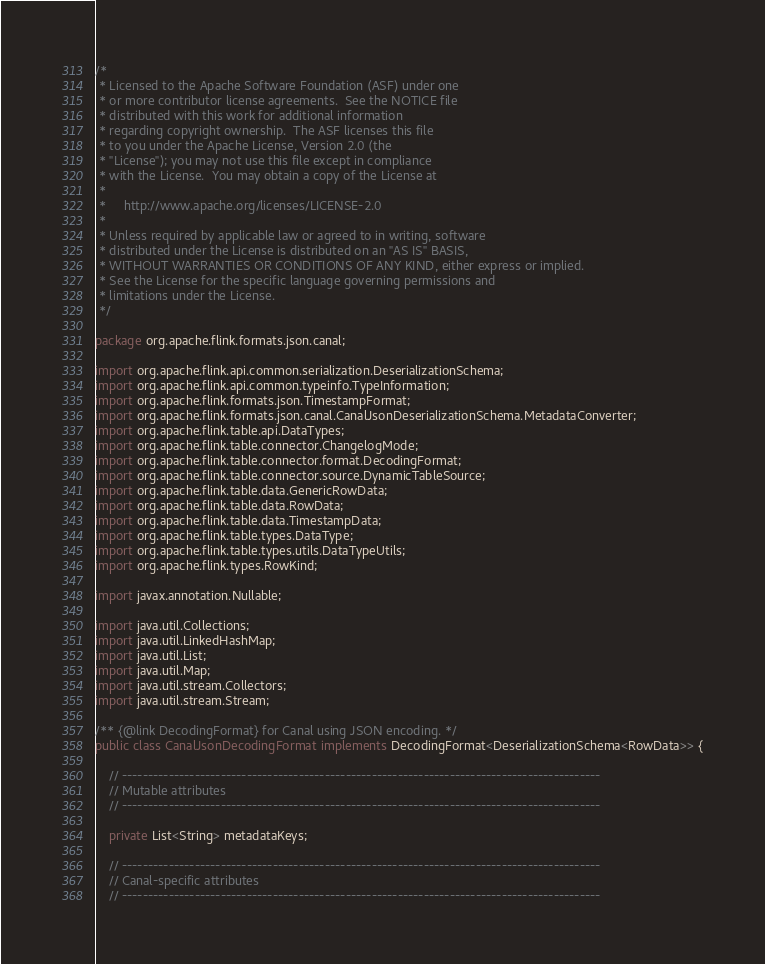Convert code to text. <code><loc_0><loc_0><loc_500><loc_500><_Java_>/*
 * Licensed to the Apache Software Foundation (ASF) under one
 * or more contributor license agreements.  See the NOTICE file
 * distributed with this work for additional information
 * regarding copyright ownership.  The ASF licenses this file
 * to you under the Apache License, Version 2.0 (the
 * "License"); you may not use this file except in compliance
 * with the License.  You may obtain a copy of the License at
 *
 *     http://www.apache.org/licenses/LICENSE-2.0
 *
 * Unless required by applicable law or agreed to in writing, software
 * distributed under the License is distributed on an "AS IS" BASIS,
 * WITHOUT WARRANTIES OR CONDITIONS OF ANY KIND, either express or implied.
 * See the License for the specific language governing permissions and
 * limitations under the License.
 */

package org.apache.flink.formats.json.canal;

import org.apache.flink.api.common.serialization.DeserializationSchema;
import org.apache.flink.api.common.typeinfo.TypeInformation;
import org.apache.flink.formats.json.TimestampFormat;
import org.apache.flink.formats.json.canal.CanalJsonDeserializationSchema.MetadataConverter;
import org.apache.flink.table.api.DataTypes;
import org.apache.flink.table.connector.ChangelogMode;
import org.apache.flink.table.connector.format.DecodingFormat;
import org.apache.flink.table.connector.source.DynamicTableSource;
import org.apache.flink.table.data.GenericRowData;
import org.apache.flink.table.data.RowData;
import org.apache.flink.table.data.TimestampData;
import org.apache.flink.table.types.DataType;
import org.apache.flink.table.types.utils.DataTypeUtils;
import org.apache.flink.types.RowKind;

import javax.annotation.Nullable;

import java.util.Collections;
import java.util.LinkedHashMap;
import java.util.List;
import java.util.Map;
import java.util.stream.Collectors;
import java.util.stream.Stream;

/** {@link DecodingFormat} for Canal using JSON encoding. */
public class CanalJsonDecodingFormat implements DecodingFormat<DeserializationSchema<RowData>> {

    // --------------------------------------------------------------------------------------------
    // Mutable attributes
    // --------------------------------------------------------------------------------------------

    private List<String> metadataKeys;

    // --------------------------------------------------------------------------------------------
    // Canal-specific attributes
    // --------------------------------------------------------------------------------------------
</code> 